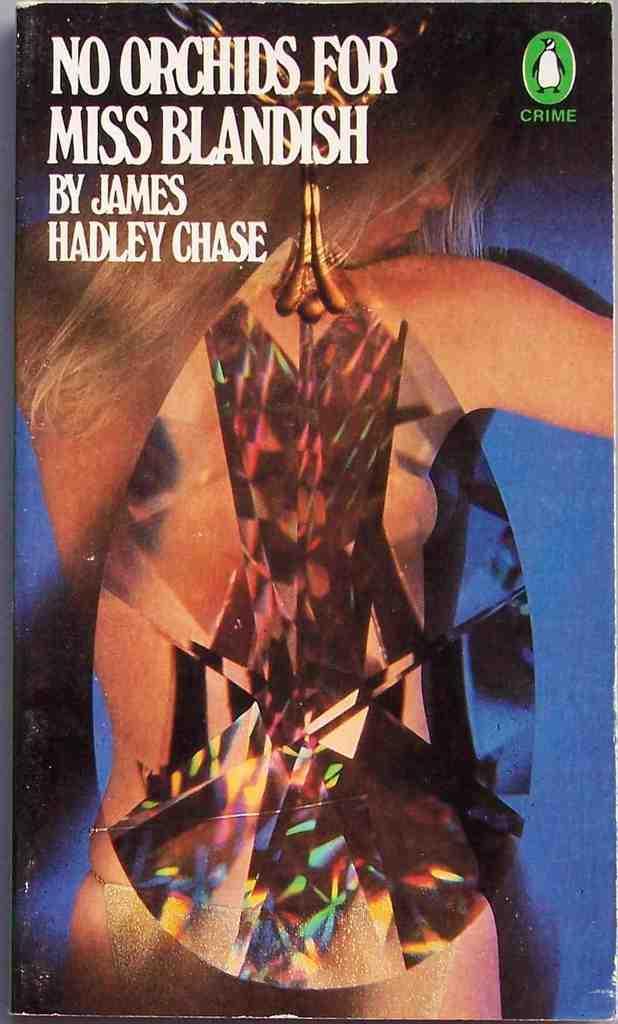How would you summarize this image in a sentence or two? This picture contains the poster of the woman. At the top of the picture, we see some text written. In the background, it is blue in color. 